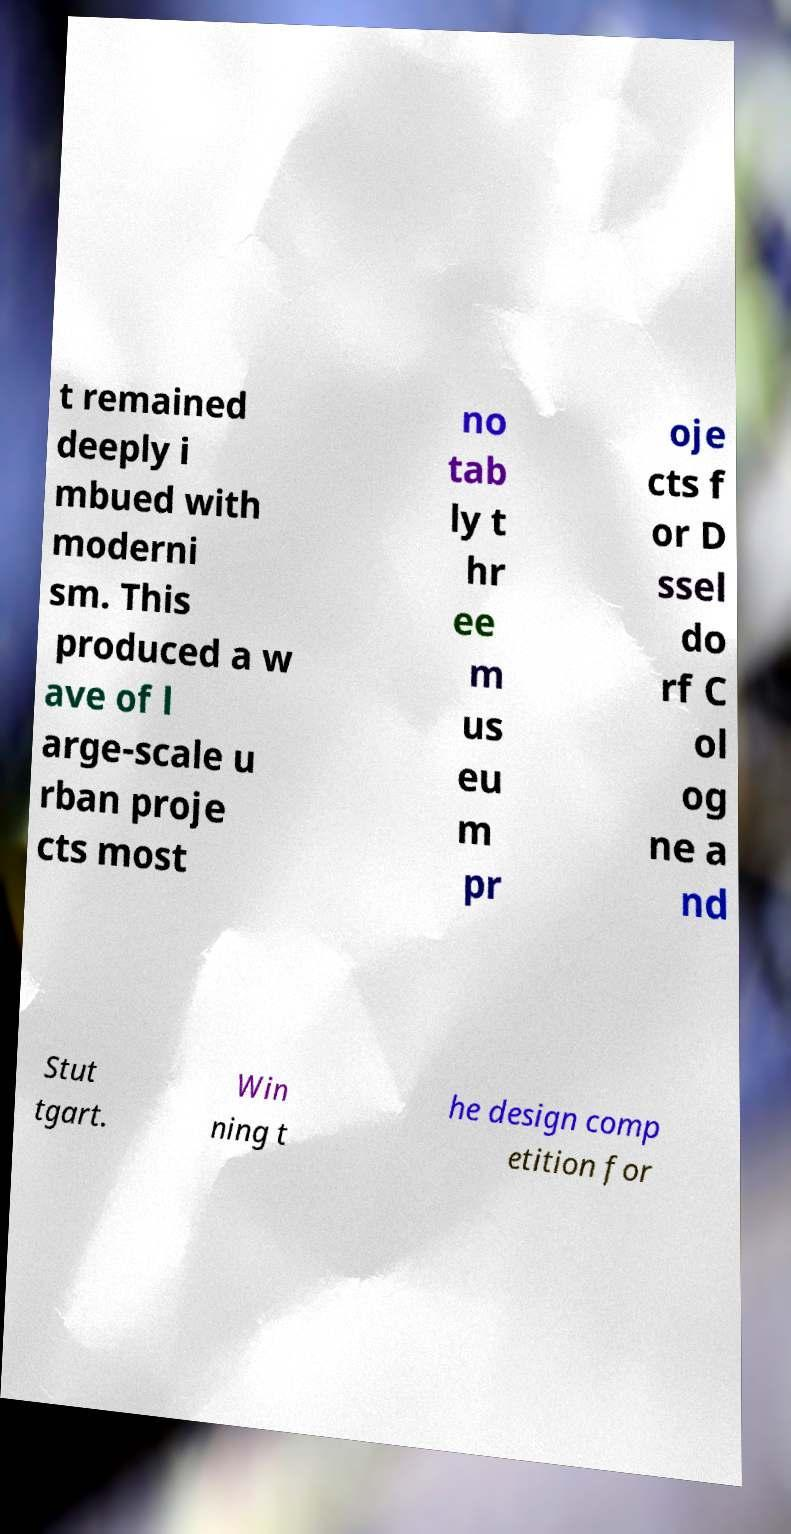Could you extract and type out the text from this image? t remained deeply i mbued with moderni sm. This produced a w ave of l arge-scale u rban proje cts most no tab ly t hr ee m us eu m pr oje cts f or D ssel do rf C ol og ne a nd Stut tgart. Win ning t he design comp etition for 